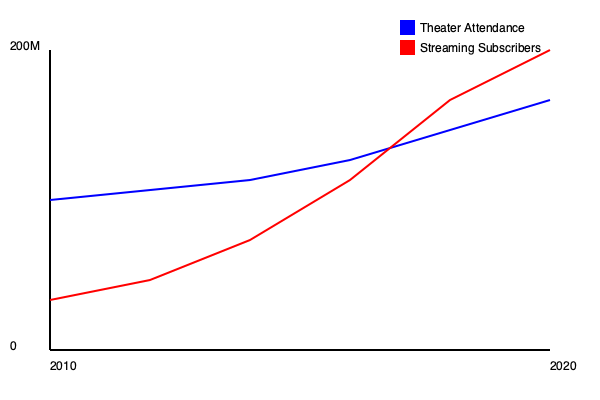Based on the graph showing theater attendance and streaming subscribers from 2010 to 2020, at approximately what year did the number of streaming subscribers surpass theater attendance? What implications does this crossover point have for the film industry? To answer this question, we need to analyze the graph and follow these steps:

1. Identify the lines: 
   - Blue line represents theater attendance
   - Red line represents streaming subscribers

2. Locate the intersection point:
   The two lines cross each other around the middle of the graph.

3. Estimate the year of intersection:
   The x-axis represents years from 2010 to 2020. The intersection occurs slightly after the midpoint, which would be around 2015-2016.

4. Implications for the film industry:
   a) Shift in audience behavior: More people are choosing to watch content at home rather than in theaters.
   b) Revenue streams: Studios may need to adapt their distribution strategies to capitalize on streaming platforms.
   c) Production decisions: Films may be produced with streaming platforms in mind, potentially affecting budgets and creative choices.
   d) Theater experience: Cinemas may need to innovate to attract audiences, such as offering premium experiences.
   e) Release windows: The traditional theatrical release window may shrink or become more flexible.

5. Conclusion:
   The crossover point represents a significant shift in the industry, marking the moment when streaming became the dominant form of film consumption. This change has far-reaching consequences for how films are produced, distributed, and consumed.
Answer: Around 2015-2016; signifies a major shift in film consumption patterns, necessitating industry-wide adaptations in production, distribution, and exhibition strategies. 